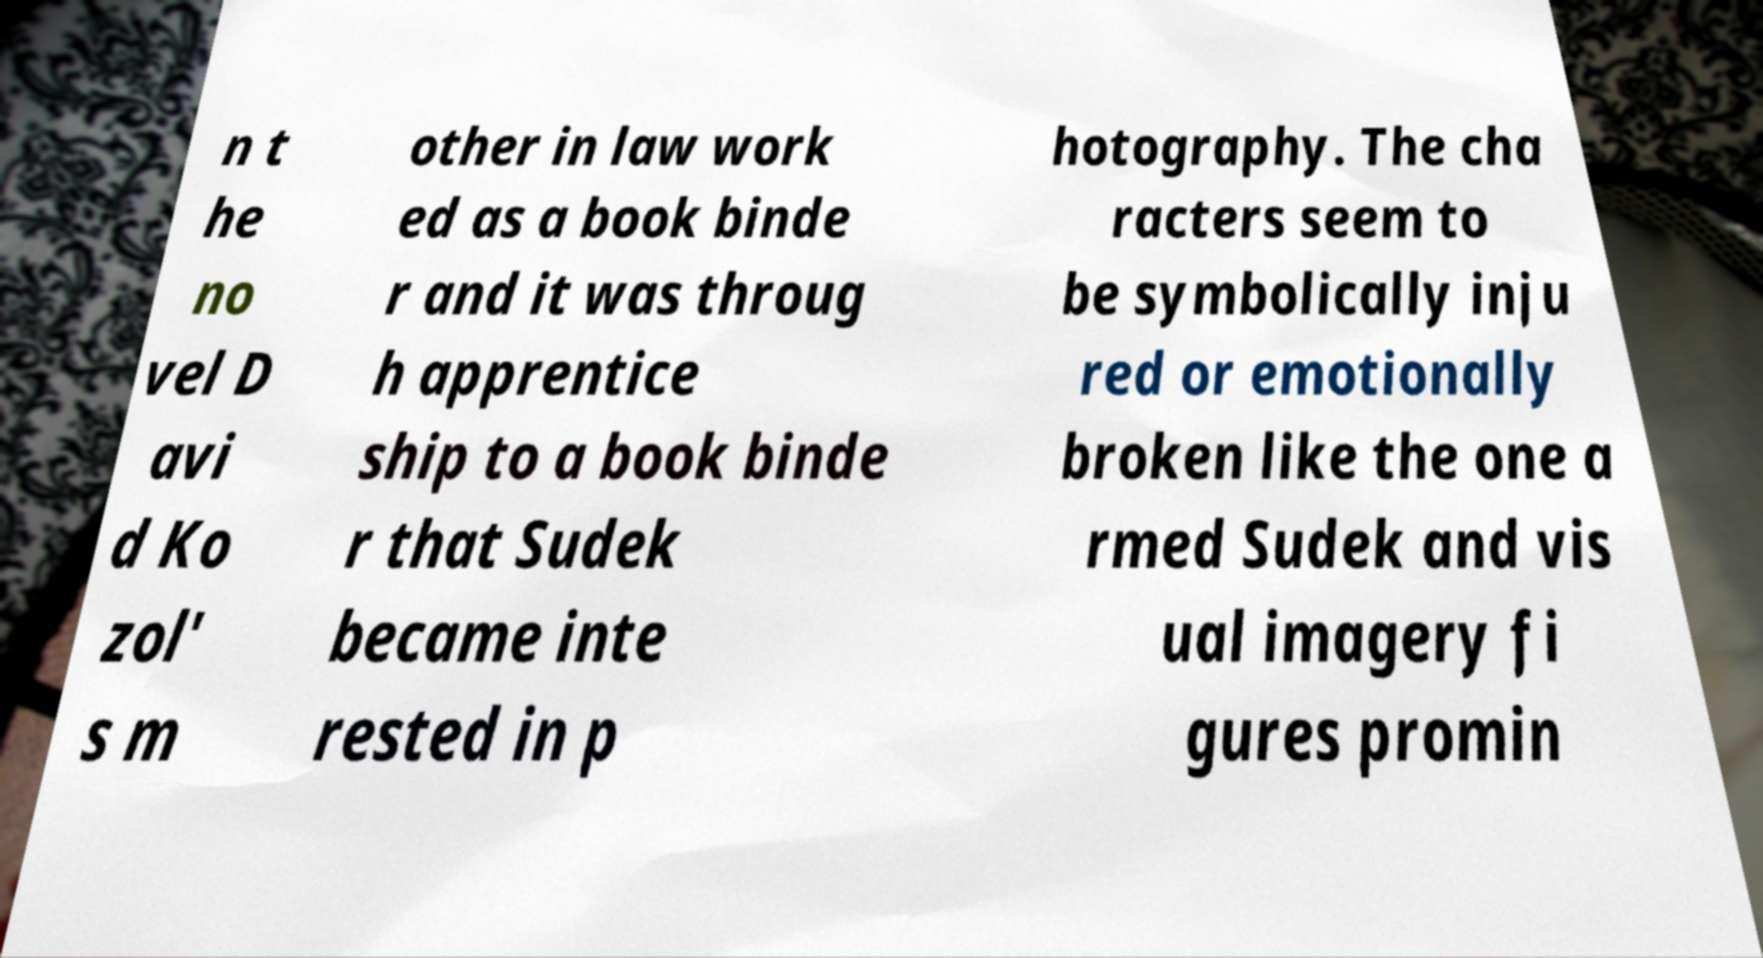Could you extract and type out the text from this image? n t he no vel D avi d Ko zol' s m other in law work ed as a book binde r and it was throug h apprentice ship to a book binde r that Sudek became inte rested in p hotography. The cha racters seem to be symbolically inju red or emotionally broken like the one a rmed Sudek and vis ual imagery fi gures promin 